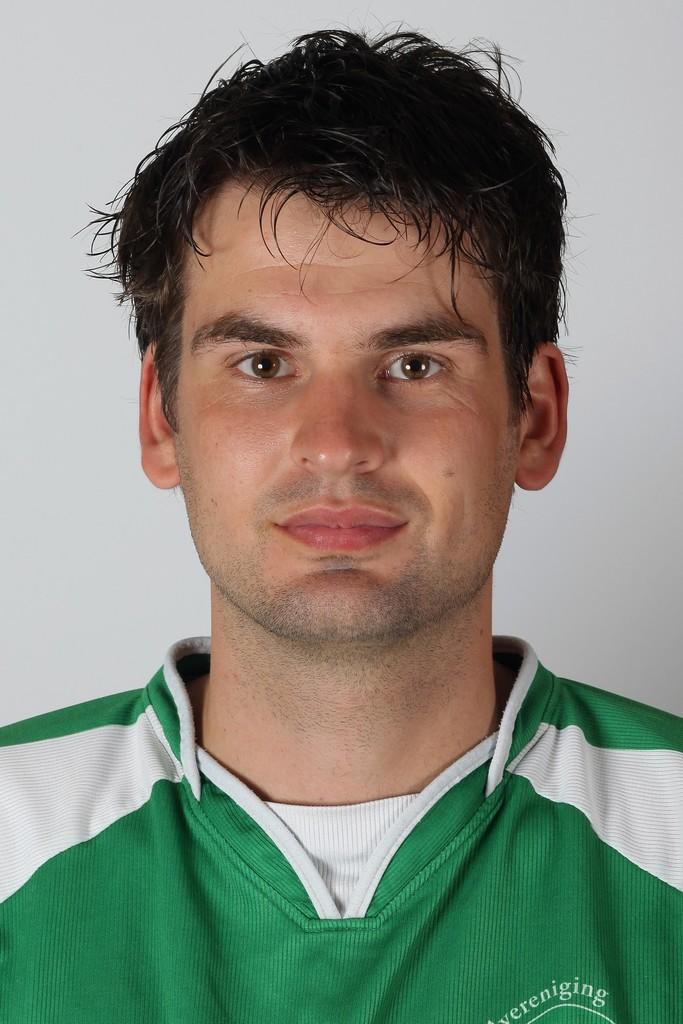Who is present in the image? There is a man in the image. What can be seen in the background of the image? There is a wall in the background of the image. What type of animal is depicted in the image? There is no animal present in the image; it features a man and a wall in the background. 